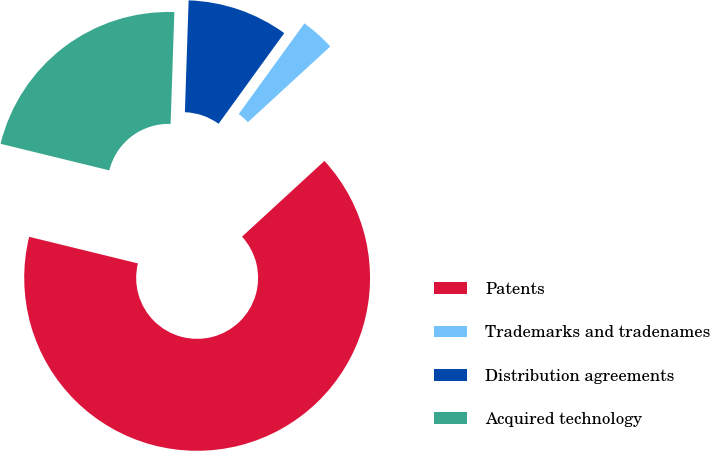Convert chart. <chart><loc_0><loc_0><loc_500><loc_500><pie_chart><fcel>Patents<fcel>Trademarks and tradenames<fcel>Distribution agreements<fcel>Acquired technology<nl><fcel>65.65%<fcel>3.2%<fcel>9.44%<fcel>21.72%<nl></chart> 